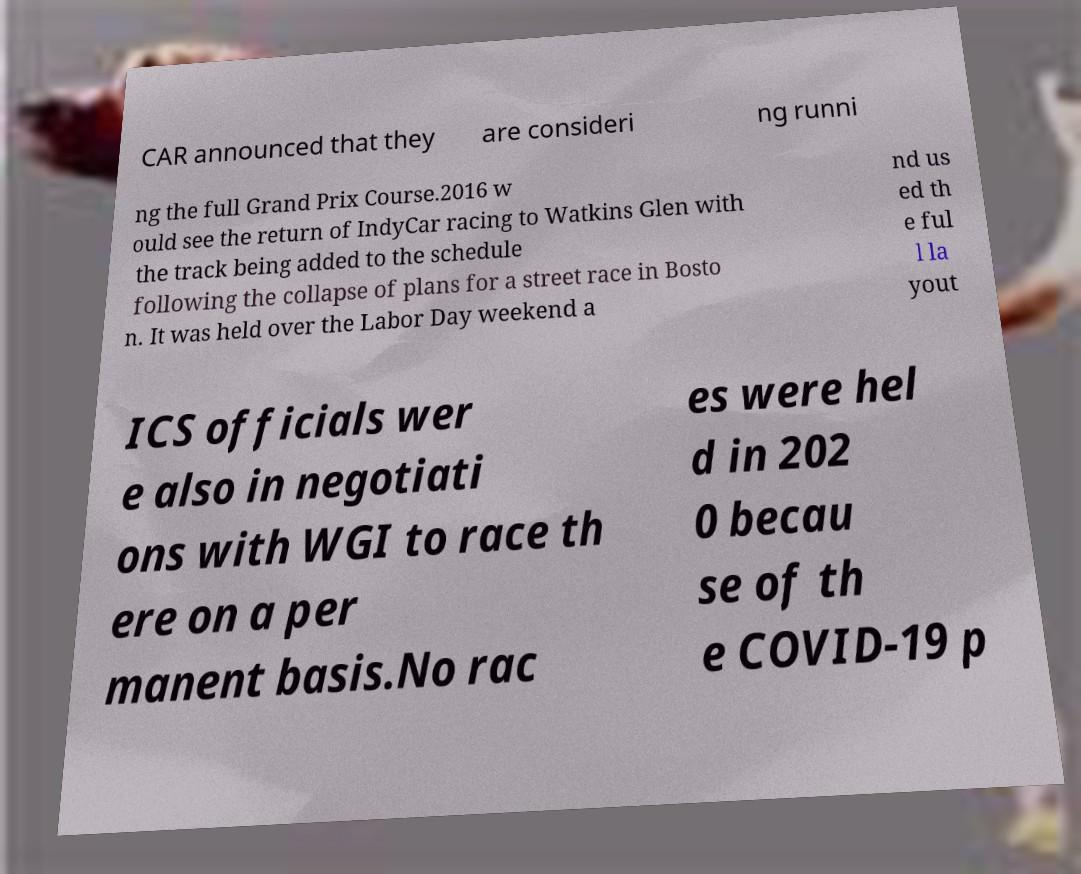For documentation purposes, I need the text within this image transcribed. Could you provide that? CAR announced that they are consideri ng runni ng the full Grand Prix Course.2016 w ould see the return of IndyCar racing to Watkins Glen with the track being added to the schedule following the collapse of plans for a street race in Bosto n. It was held over the Labor Day weekend a nd us ed th e ful l la yout ICS officials wer e also in negotiati ons with WGI to race th ere on a per manent basis.No rac es were hel d in 202 0 becau se of th e COVID-19 p 